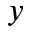Convert formula to latex. <formula><loc_0><loc_0><loc_500><loc_500>y</formula> 